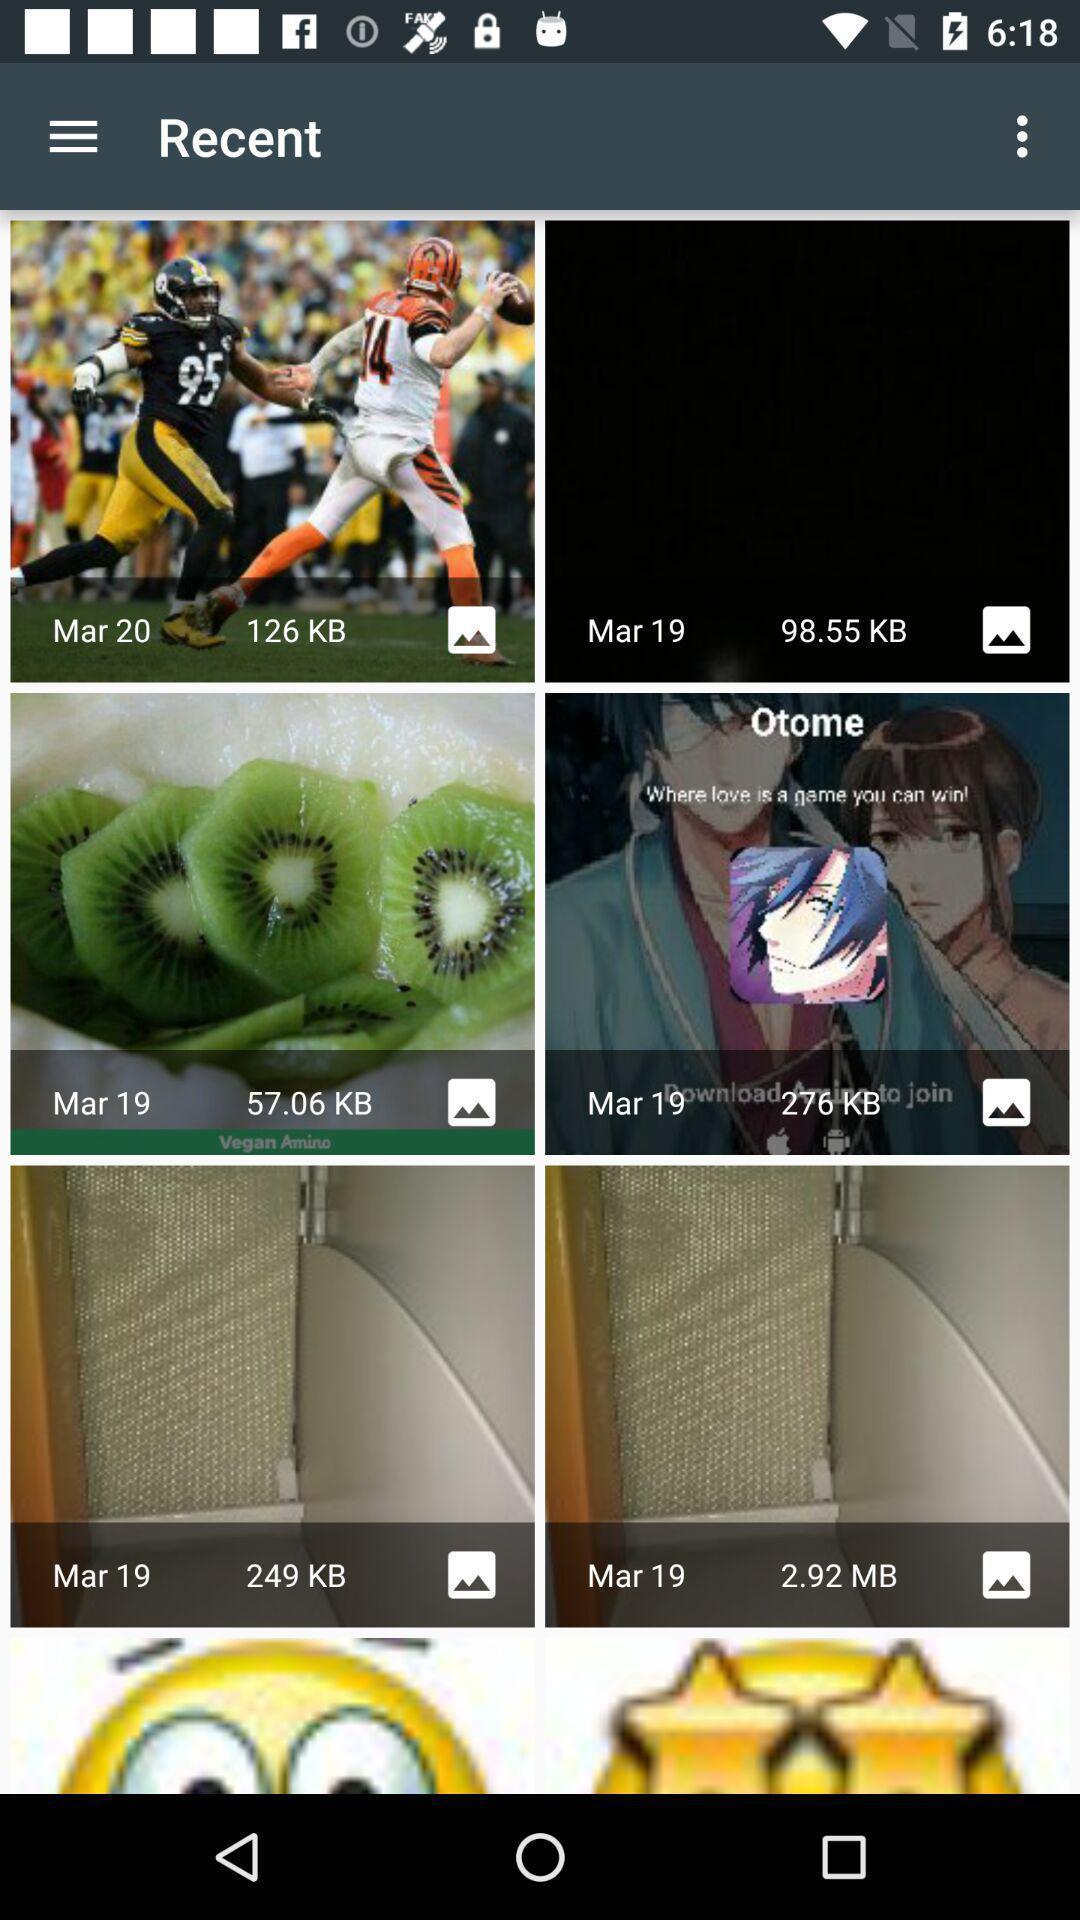Give me a summary of this screen capture. Page showing images in a gallery app. 